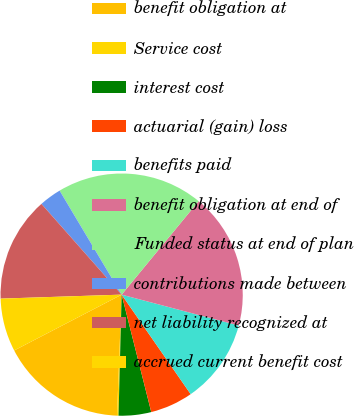<chart> <loc_0><loc_0><loc_500><loc_500><pie_chart><fcel>benefit obligation at<fcel>Service cost<fcel>interest cost<fcel>actuarial (gain) loss<fcel>benefits paid<fcel>benefit obligation at end of<fcel>Funded status at end of plan<fcel>contributions made between<fcel>net liability recognized at<fcel>accrued current benefit cost<nl><fcel>16.76%<fcel>0.2%<fcel>4.34%<fcel>5.72%<fcel>11.24%<fcel>18.14%<fcel>19.52%<fcel>2.96%<fcel>14.0%<fcel>7.1%<nl></chart> 